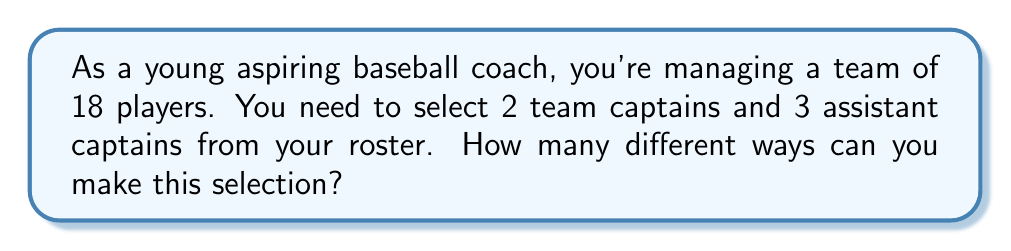Could you help me with this problem? Let's break this down step-by-step:

1) First, we need to select 2 team captains from 18 players. This is a combination problem, as the order of selection doesn't matter. We use the combination formula:

   $${18 \choose 2} = \frac{18!}{2!(18-2)!} = \frac{18!}{2!16!} = 153$$

2) After selecting the captains, we have 16 players left, from which we need to select 3 assistant captains. Again, this is a combination:

   $${16 \choose 3} = \frac{16!}{3!(16-3)!} = \frac{16!}{3!13!} = 560$$

3) By the Multiplication Principle, the total number of ways to select both captains and assistant captains is the product of these two combinations:

   $$153 \times 560 = 85,680$$

This calculation gives us the total number of unique ways to select 2 captains and 3 assistant captains from a team of 18 players.
Answer: 85,680 ways 